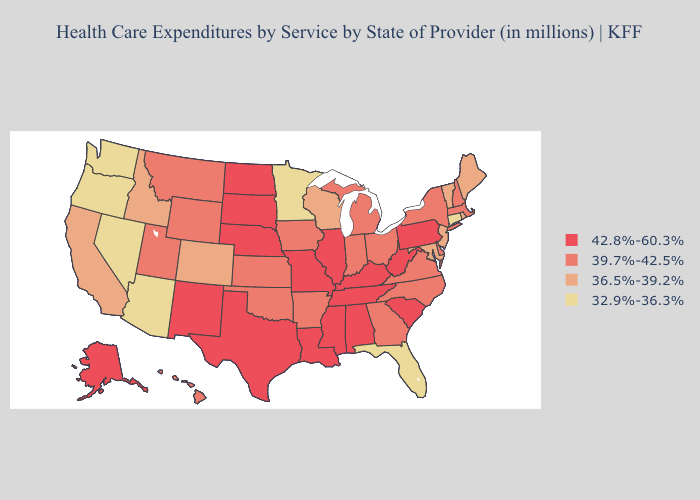Does South Carolina have the lowest value in the USA?
Answer briefly. No. Name the states that have a value in the range 42.8%-60.3%?
Short answer required. Alabama, Alaska, Illinois, Kentucky, Louisiana, Mississippi, Missouri, Nebraska, New Mexico, North Dakota, Pennsylvania, South Carolina, South Dakota, Tennessee, Texas, West Virginia. Does Arkansas have the highest value in the USA?
Keep it brief. No. What is the value of Vermont?
Be succinct. 36.5%-39.2%. What is the lowest value in the MidWest?
Keep it brief. 32.9%-36.3%. Which states have the highest value in the USA?
Answer briefly. Alabama, Alaska, Illinois, Kentucky, Louisiana, Mississippi, Missouri, Nebraska, New Mexico, North Dakota, Pennsylvania, South Carolina, South Dakota, Tennessee, Texas, West Virginia. What is the lowest value in the USA?
Keep it brief. 32.9%-36.3%. Does Nevada have a lower value than New Hampshire?
Answer briefly. Yes. What is the value of Louisiana?
Write a very short answer. 42.8%-60.3%. Does New Mexico have the lowest value in the USA?
Short answer required. No. Name the states that have a value in the range 39.7%-42.5%?
Concise answer only. Arkansas, Delaware, Georgia, Hawaii, Indiana, Iowa, Kansas, Massachusetts, Michigan, Montana, New Hampshire, New York, North Carolina, Ohio, Oklahoma, Utah, Virginia, Wyoming. Among the states that border Delaware , which have the lowest value?
Be succinct. Maryland, New Jersey. Name the states that have a value in the range 39.7%-42.5%?
Answer briefly. Arkansas, Delaware, Georgia, Hawaii, Indiana, Iowa, Kansas, Massachusetts, Michigan, Montana, New Hampshire, New York, North Carolina, Ohio, Oklahoma, Utah, Virginia, Wyoming. Does Vermont have the same value as Alaska?
Concise answer only. No. Does the map have missing data?
Give a very brief answer. No. 